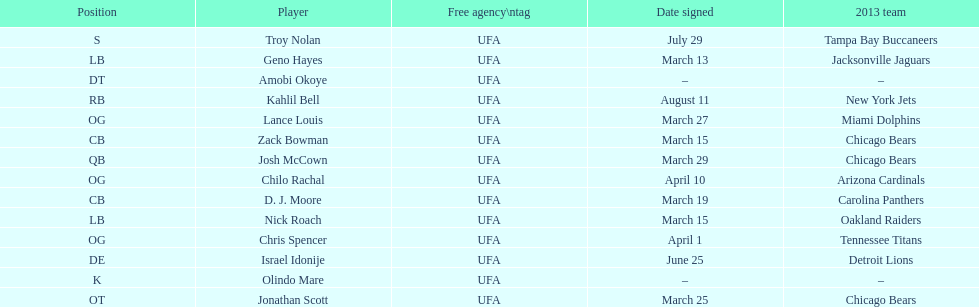Who was the previous player signed before troy nolan? Israel Idonije. 